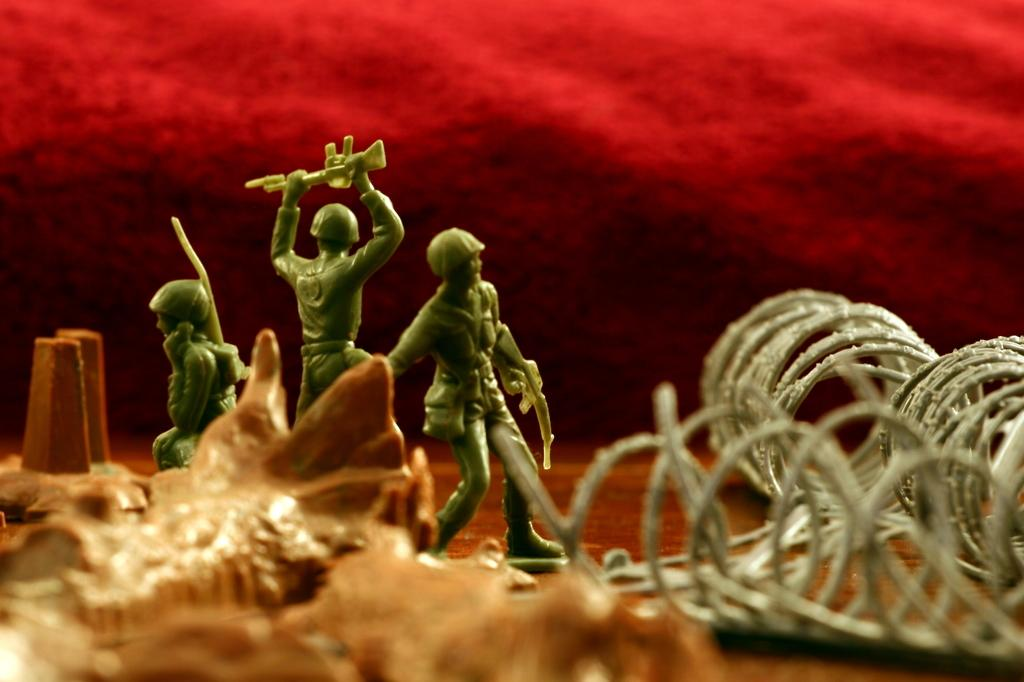What type of objects can be seen in the image? There are toys in the image. What can be seen beneath the toys in the image? The ground is visible in the image. Where is the object located in the image? There is an object on the bottom left side of the image. What color is the background of the image? The background of the image is red. Can you tell me how many vests are being sold in the shop in the image? There is no shop or vests present in the image; it features toys and a red background. 